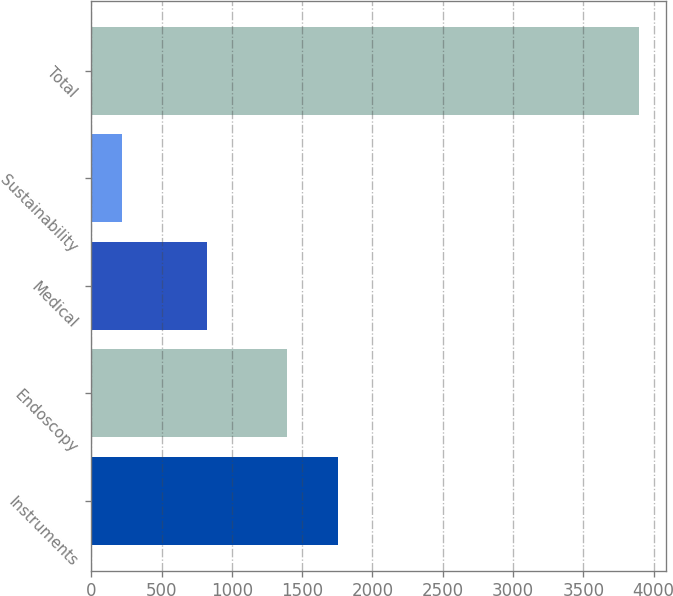Convert chart. <chart><loc_0><loc_0><loc_500><loc_500><bar_chart><fcel>Instruments<fcel>Endoscopy<fcel>Medical<fcel>Sustainability<fcel>Total<nl><fcel>1757.9<fcel>1390<fcel>823<fcel>216<fcel>3895<nl></chart> 